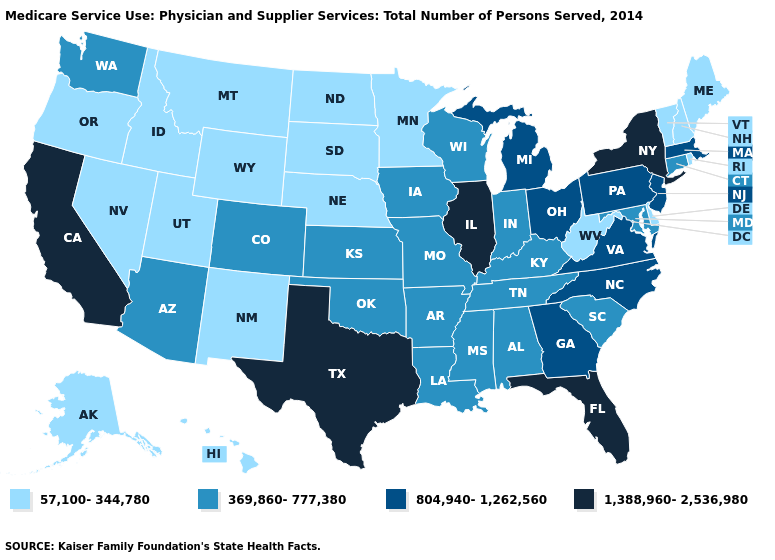What is the lowest value in states that border North Carolina?
Concise answer only. 369,860-777,380. Which states have the highest value in the USA?
Write a very short answer. California, Florida, Illinois, New York, Texas. Does Texas have the highest value in the South?
Answer briefly. Yes. Which states have the lowest value in the USA?
Short answer required. Alaska, Delaware, Hawaii, Idaho, Maine, Minnesota, Montana, Nebraska, Nevada, New Hampshire, New Mexico, North Dakota, Oregon, Rhode Island, South Dakota, Utah, Vermont, West Virginia, Wyoming. Does Missouri have a lower value than Arkansas?
Short answer required. No. Which states have the lowest value in the Northeast?
Write a very short answer. Maine, New Hampshire, Rhode Island, Vermont. Among the states that border Oregon , which have the lowest value?
Write a very short answer. Idaho, Nevada. Among the states that border Georgia , which have the lowest value?
Give a very brief answer. Alabama, South Carolina, Tennessee. Name the states that have a value in the range 369,860-777,380?
Short answer required. Alabama, Arizona, Arkansas, Colorado, Connecticut, Indiana, Iowa, Kansas, Kentucky, Louisiana, Maryland, Mississippi, Missouri, Oklahoma, South Carolina, Tennessee, Washington, Wisconsin. What is the value of Wisconsin?
Concise answer only. 369,860-777,380. Which states hav the highest value in the South?
Write a very short answer. Florida, Texas. Does the first symbol in the legend represent the smallest category?
Short answer required. Yes. What is the lowest value in the USA?
Write a very short answer. 57,100-344,780. Which states have the lowest value in the MidWest?
Quick response, please. Minnesota, Nebraska, North Dakota, South Dakota. How many symbols are there in the legend?
Short answer required. 4. 